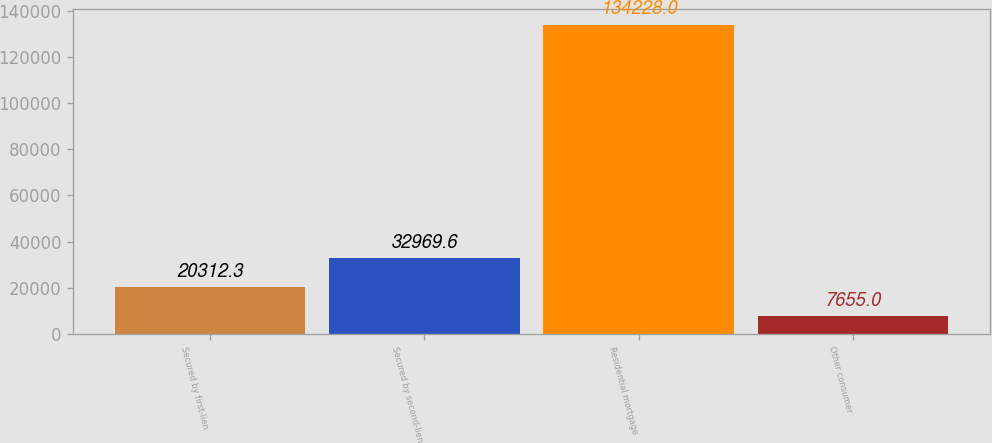<chart> <loc_0><loc_0><loc_500><loc_500><bar_chart><fcel>Secured by first-lien<fcel>Secured by second-lien<fcel>Residential mortgage<fcel>Other consumer<nl><fcel>20312.3<fcel>32969.6<fcel>134228<fcel>7655<nl></chart> 